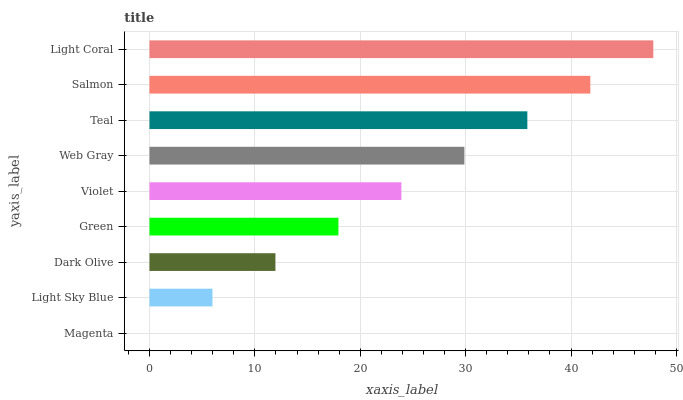Is Magenta the minimum?
Answer yes or no. Yes. Is Light Coral the maximum?
Answer yes or no. Yes. Is Light Sky Blue the minimum?
Answer yes or no. No. Is Light Sky Blue the maximum?
Answer yes or no. No. Is Light Sky Blue greater than Magenta?
Answer yes or no. Yes. Is Magenta less than Light Sky Blue?
Answer yes or no. Yes. Is Magenta greater than Light Sky Blue?
Answer yes or no. No. Is Light Sky Blue less than Magenta?
Answer yes or no. No. Is Violet the high median?
Answer yes or no. Yes. Is Violet the low median?
Answer yes or no. Yes. Is Green the high median?
Answer yes or no. No. Is Light Sky Blue the low median?
Answer yes or no. No. 